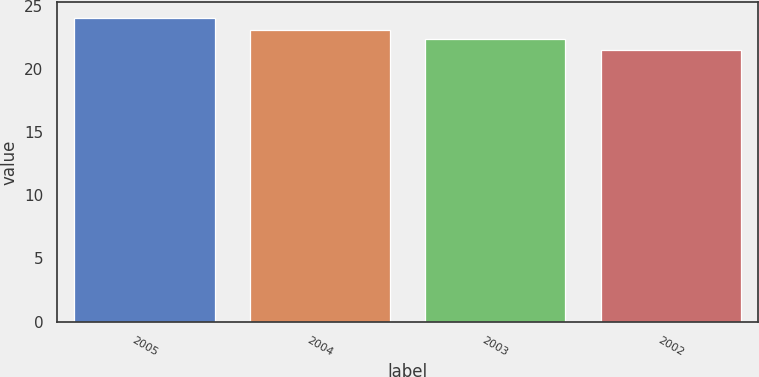<chart> <loc_0><loc_0><loc_500><loc_500><bar_chart><fcel>2005<fcel>2004<fcel>2003<fcel>2002<nl><fcel>24.04<fcel>23.08<fcel>22.35<fcel>21.46<nl></chart> 